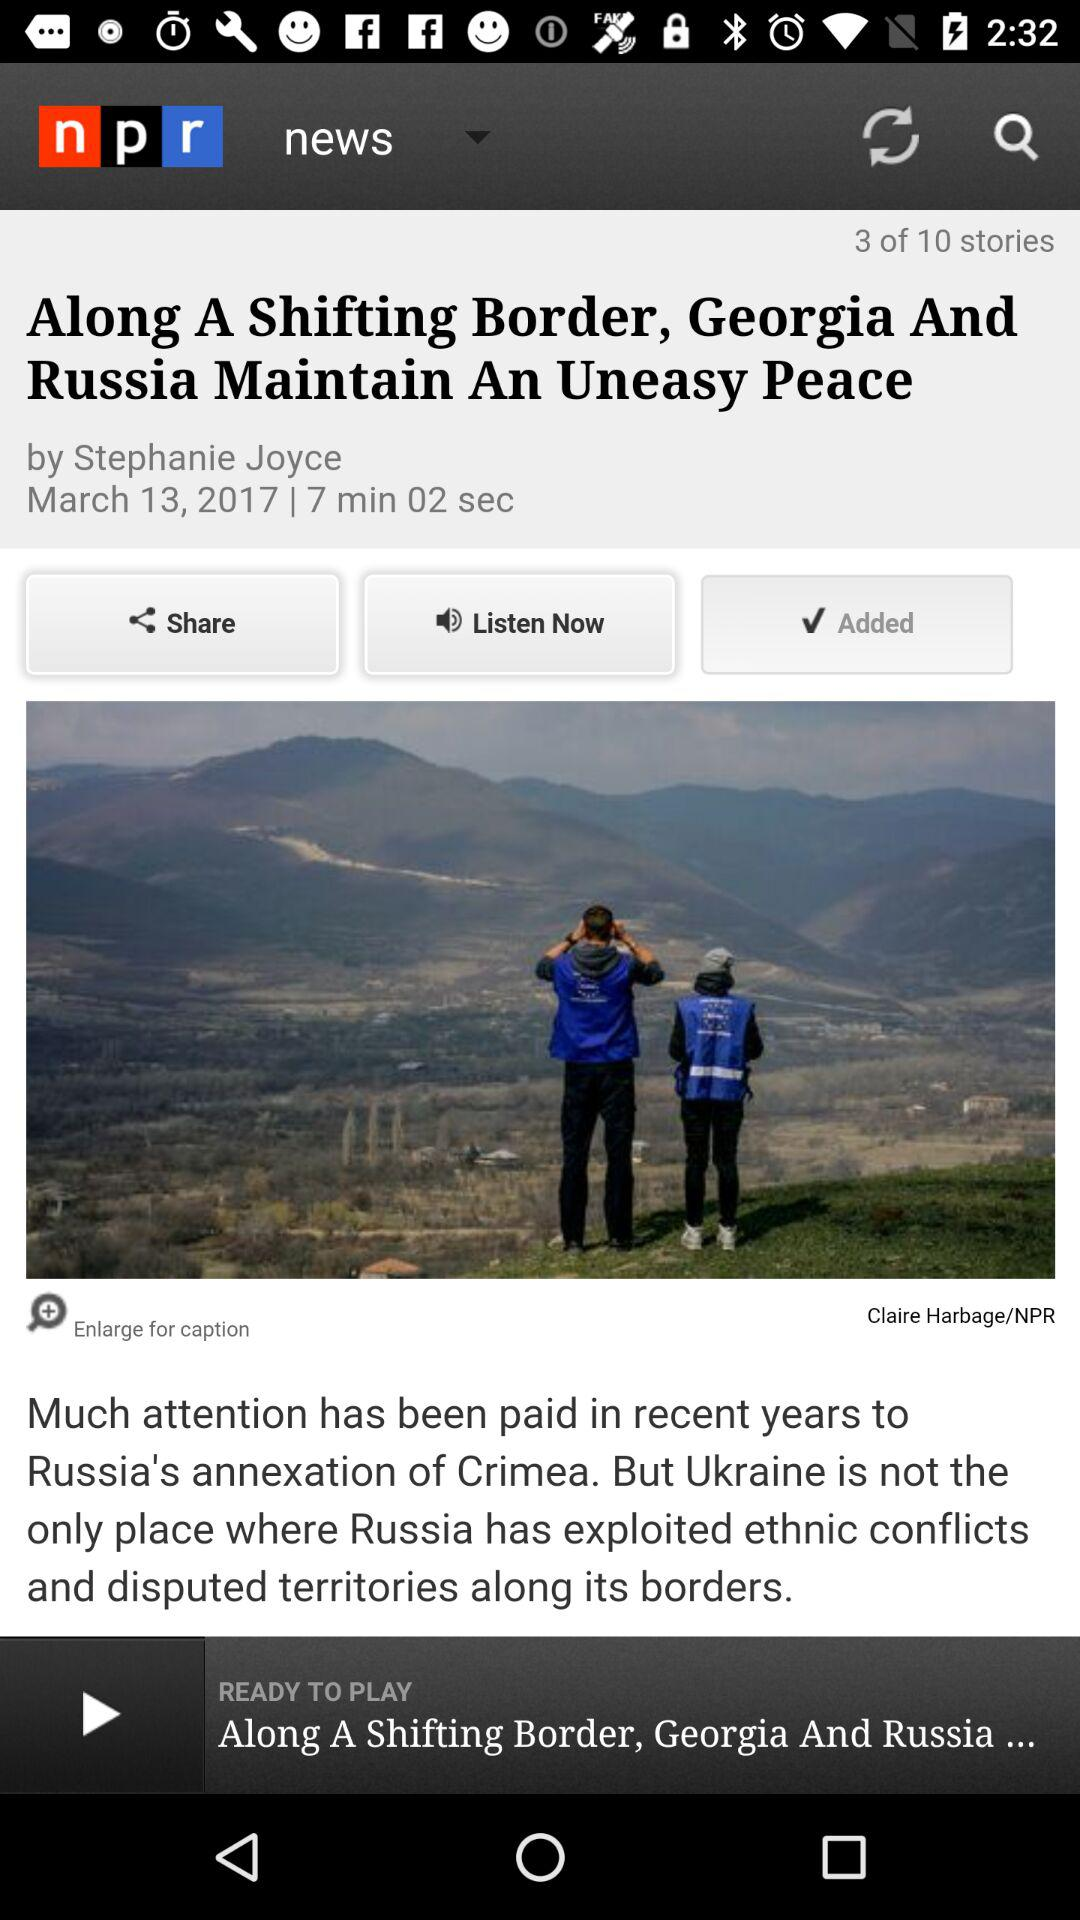Who posted the news about the leafy list of top cannabis locations?
When the provided information is insufficient, respond with <no answer>. <no answer> 